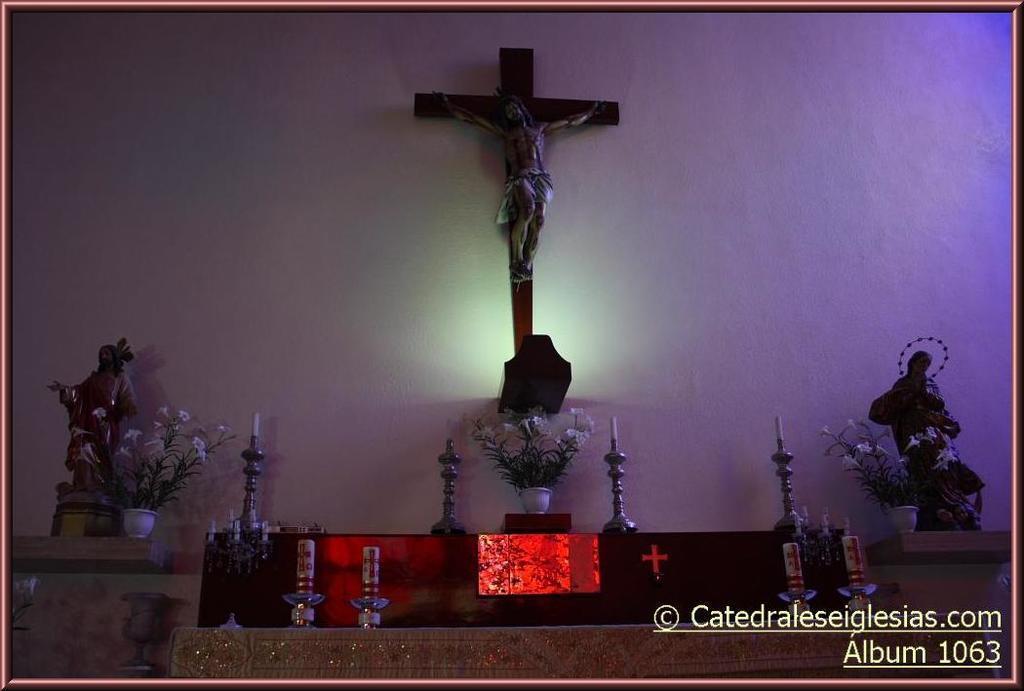Can you describe this image briefly? In this image there is a table. On the table there are candles on the candle holders and a flower vase. On either sides of the image there are shelves. On the shelves there are sculptures and flower vases. In the background there is a wall. There is a cross on the wall. There is a sculpture on the cross. In the bottom right there is text on the image. 